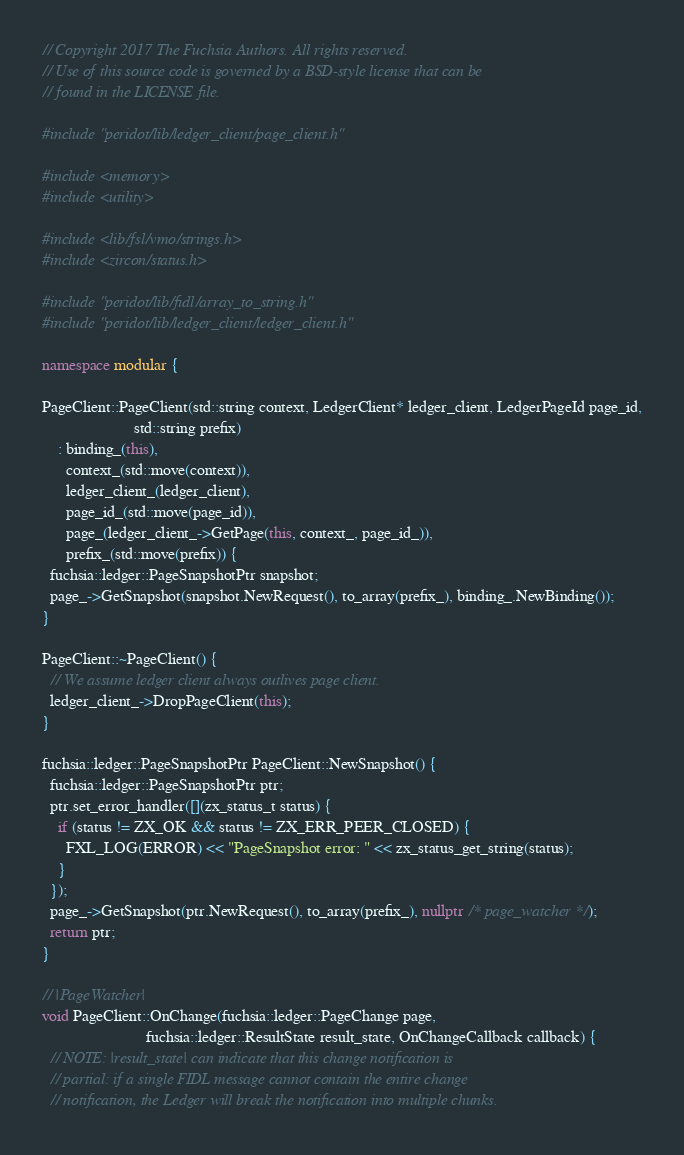<code> <loc_0><loc_0><loc_500><loc_500><_C++_>// Copyright 2017 The Fuchsia Authors. All rights reserved.
// Use of this source code is governed by a BSD-style license that can be
// found in the LICENSE file.

#include "peridot/lib/ledger_client/page_client.h"

#include <memory>
#include <utility>

#include <lib/fsl/vmo/strings.h>
#include <zircon/status.h>

#include "peridot/lib/fidl/array_to_string.h"
#include "peridot/lib/ledger_client/ledger_client.h"

namespace modular {

PageClient::PageClient(std::string context, LedgerClient* ledger_client, LedgerPageId page_id,
                       std::string prefix)
    : binding_(this),
      context_(std::move(context)),
      ledger_client_(ledger_client),
      page_id_(std::move(page_id)),
      page_(ledger_client_->GetPage(this, context_, page_id_)),
      prefix_(std::move(prefix)) {
  fuchsia::ledger::PageSnapshotPtr snapshot;
  page_->GetSnapshot(snapshot.NewRequest(), to_array(prefix_), binding_.NewBinding());
}

PageClient::~PageClient() {
  // We assume ledger client always outlives page client.
  ledger_client_->DropPageClient(this);
}

fuchsia::ledger::PageSnapshotPtr PageClient::NewSnapshot() {
  fuchsia::ledger::PageSnapshotPtr ptr;
  ptr.set_error_handler([](zx_status_t status) {
    if (status != ZX_OK && status != ZX_ERR_PEER_CLOSED) {
      FXL_LOG(ERROR) << "PageSnapshot error: " << zx_status_get_string(status);
    }
  });
  page_->GetSnapshot(ptr.NewRequest(), to_array(prefix_), nullptr /* page_watcher */);
  return ptr;
}

// |PageWatcher|
void PageClient::OnChange(fuchsia::ledger::PageChange page,
                          fuchsia::ledger::ResultState result_state, OnChangeCallback callback) {
  // NOTE: |result_state| can indicate that this change notification is
  // partial: if a single FIDL message cannot contain the entire change
  // notification, the Ledger will break the notification into multiple chunks.</code> 